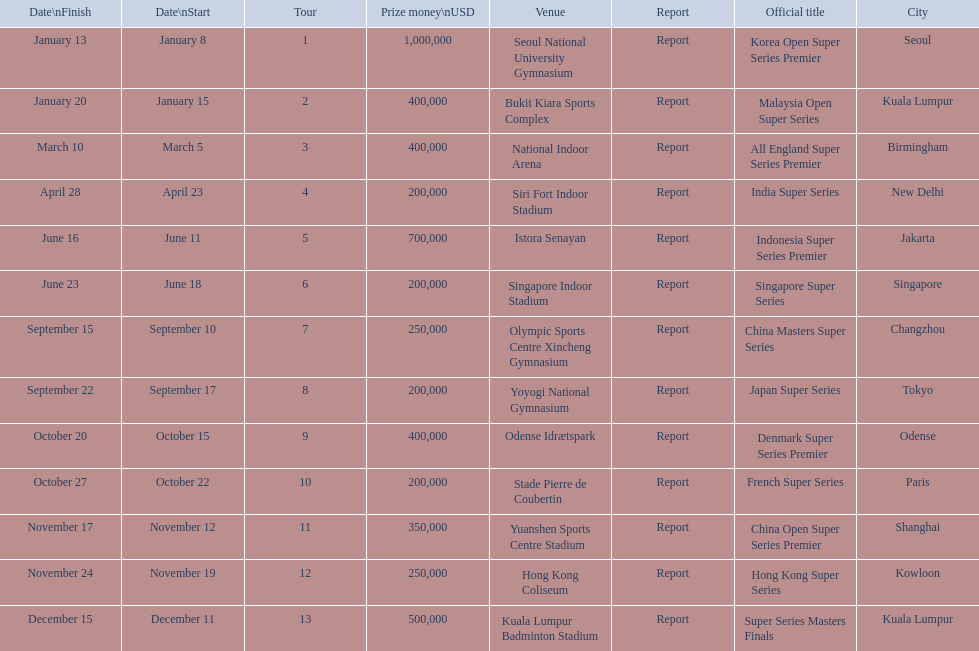Which series has the highest prize payout? Korea Open Super Series Premier. 